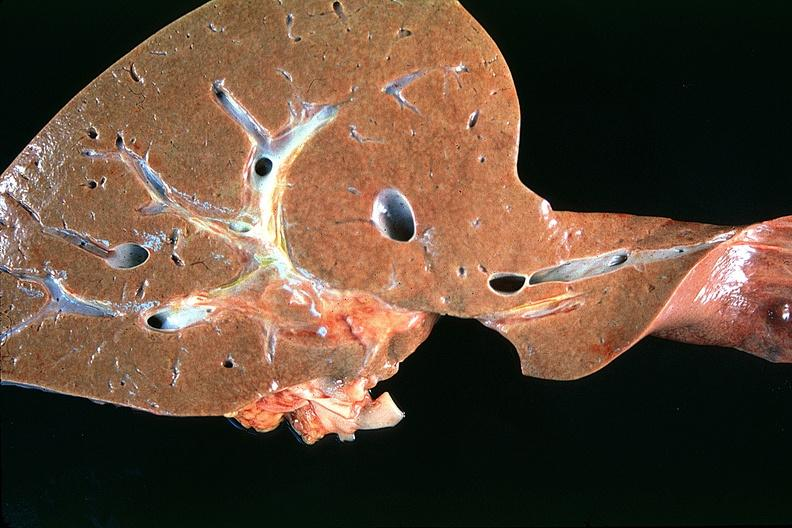s autopsy present?
Answer the question using a single word or phrase. No 